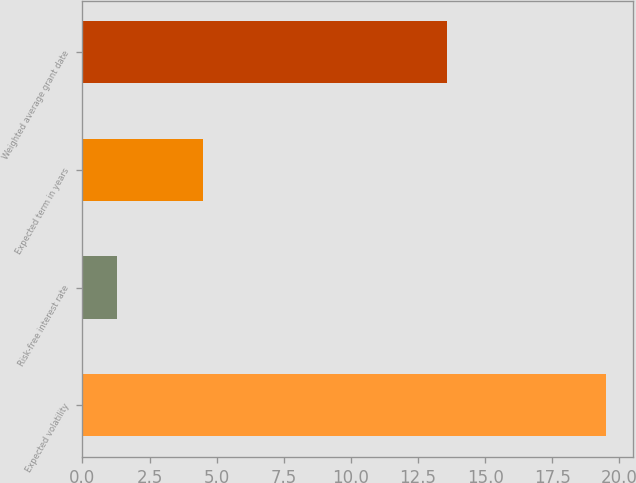Convert chart to OTSL. <chart><loc_0><loc_0><loc_500><loc_500><bar_chart><fcel>Expected volatility<fcel>Risk-free interest rate<fcel>Expected term in years<fcel>Weighted average grant date<nl><fcel>19.51<fcel>1.29<fcel>4.5<fcel>13.58<nl></chart> 